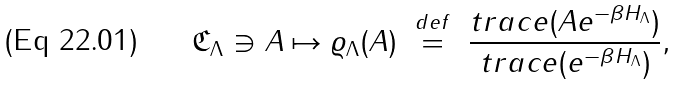<formula> <loc_0><loc_0><loc_500><loc_500>\mathfrak { C } _ { \Lambda } \ni A \mapsto \varrho _ { \Lambda } ( A ) \text { } \overset { d e f } { = } \text { } \frac { t r a c e ( A e ^ { - \beta H _ { \Lambda } } ) } { t r a c e ( e ^ { - \beta H _ { \Lambda } } ) } ,</formula> 